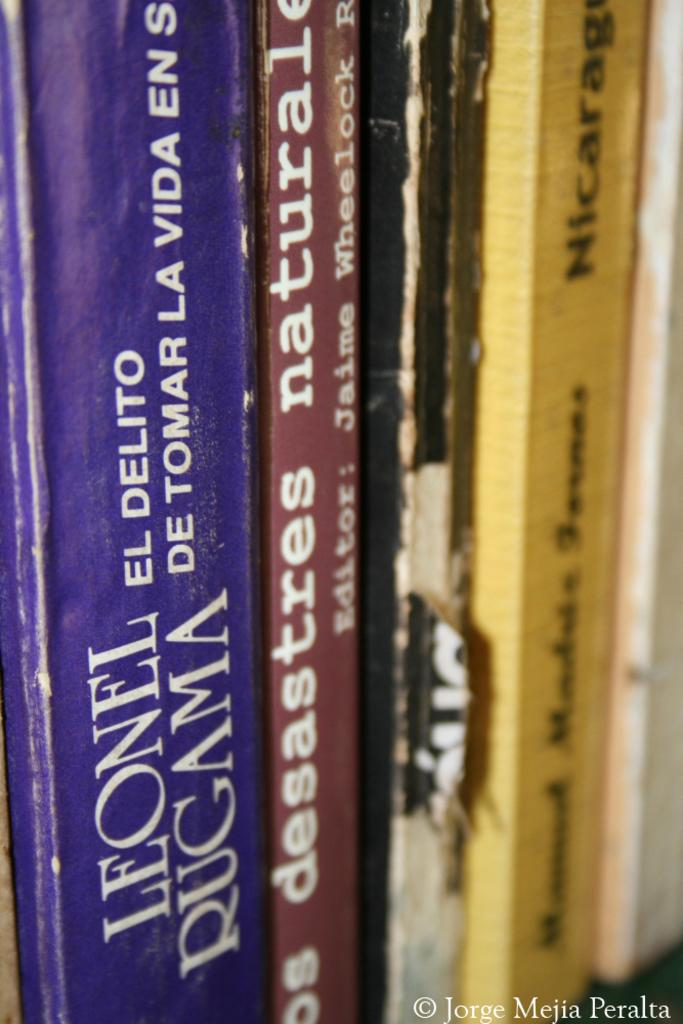<image>
Write a terse but informative summary of the picture. Book spines of various books including one by Leonel Rugama. 